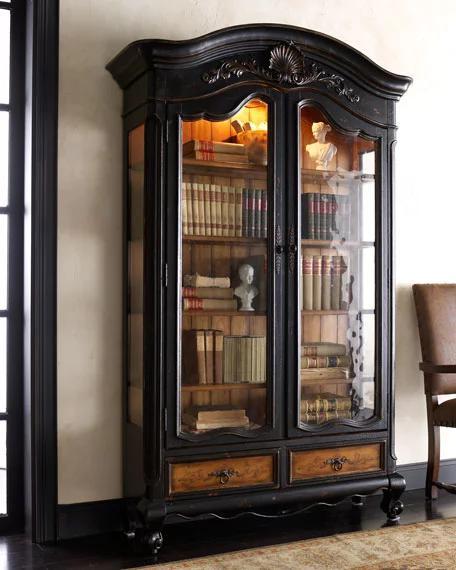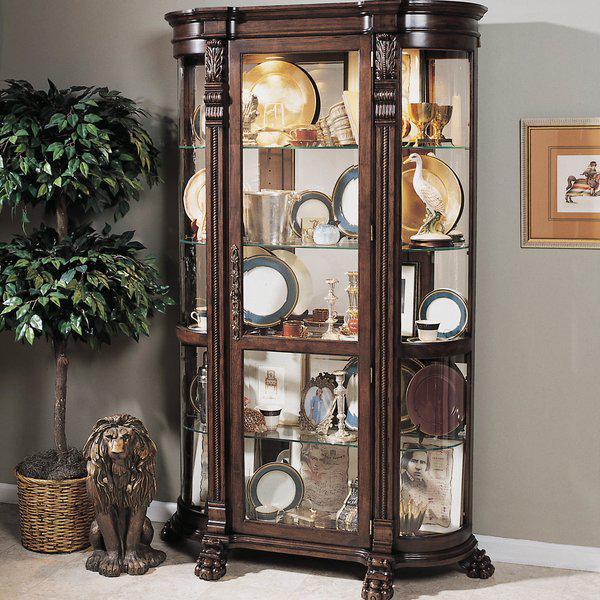The first image is the image on the left, the second image is the image on the right. Considering the images on both sides, is "An antique wooden piece in one image has a curved top, at least one glass door with an ornate window pane design, and sits on long thin legs." valid? Answer yes or no. No. The first image is the image on the left, the second image is the image on the right. Considering the images on both sides, is "The right image contains a blue china cabinet." valid? Answer yes or no. No. 